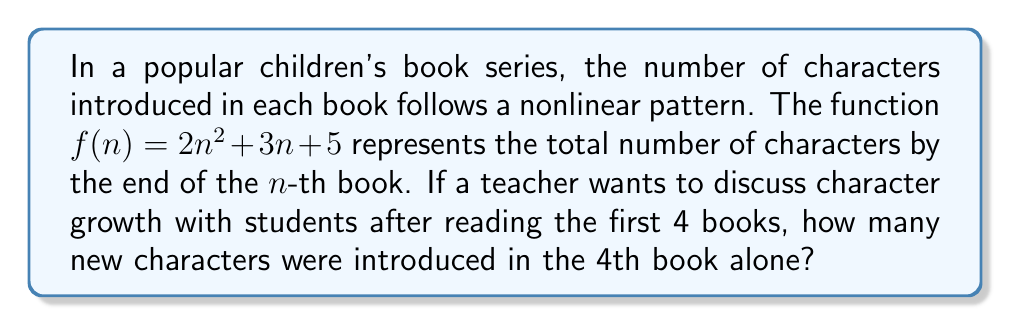Teach me how to tackle this problem. To solve this problem, we need to follow these steps:

1) First, let's calculate the total number of characters at the end of the 3rd book:
   $f(3) = 2(3)^2 + 3(3) + 5 = 18 + 9 + 5 = 32$

2) Now, let's calculate the total number of characters at the end of the 4th book:
   $f(4) = 2(4)^2 + 3(4) + 5 = 32 + 12 + 5 = 49$

3) The number of new characters introduced in the 4th book is the difference between these two values:
   $f(4) - f(3) = 49 - 32 = 17$

Therefore, 17 new characters were introduced in the 4th book.

This approach demonstrates the nonlinear growth of characters, as the number of new characters increases with each book, following a quadratic pattern.
Answer: 17 new characters 